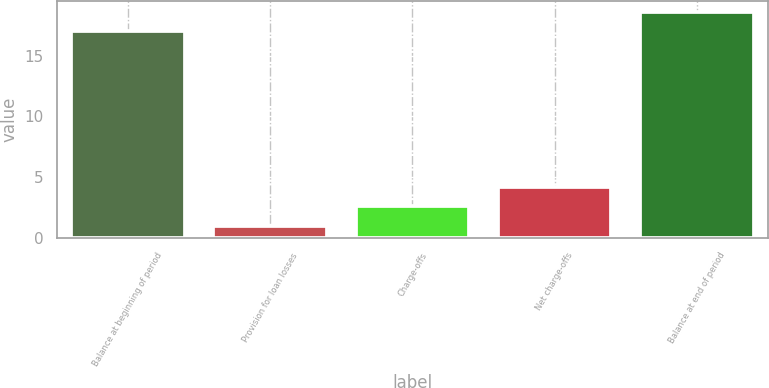<chart> <loc_0><loc_0><loc_500><loc_500><bar_chart><fcel>Balance at beginning of period<fcel>Provision for loan losses<fcel>Charge-offs<fcel>Net charge-offs<fcel>Balance at end of period<nl><fcel>17<fcel>1<fcel>2.6<fcel>4.2<fcel>18.6<nl></chart> 